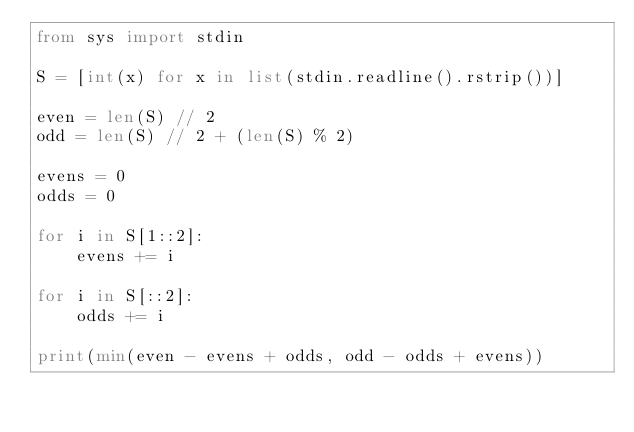<code> <loc_0><loc_0><loc_500><loc_500><_Python_>from sys import stdin

S = [int(x) for x in list(stdin.readline().rstrip())]

even = len(S) // 2
odd = len(S) // 2 + (len(S) % 2)

evens = 0
odds = 0

for i in S[1::2]:
    evens += i

for i in S[::2]:
    odds += i

print(min(even - evens + odds, odd - odds + evens))</code> 